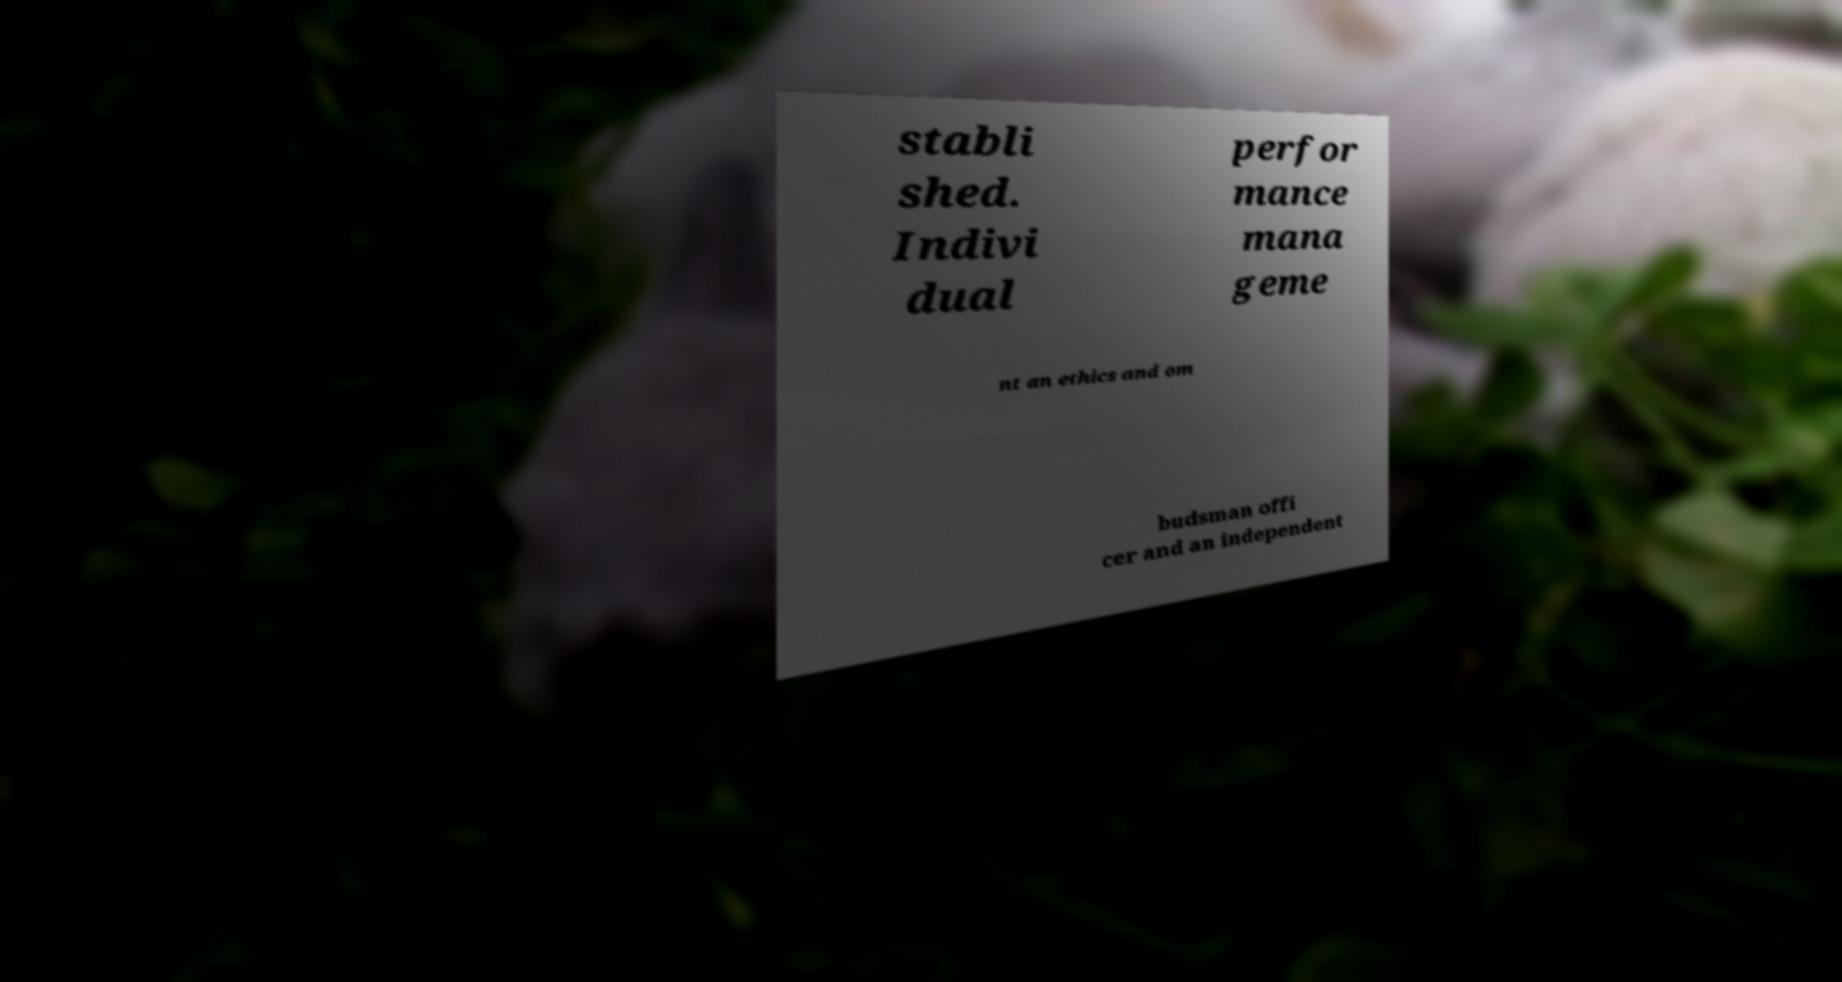Please identify and transcribe the text found in this image. stabli shed. Indivi dual perfor mance mana geme nt an ethics and om budsman offi cer and an independent 